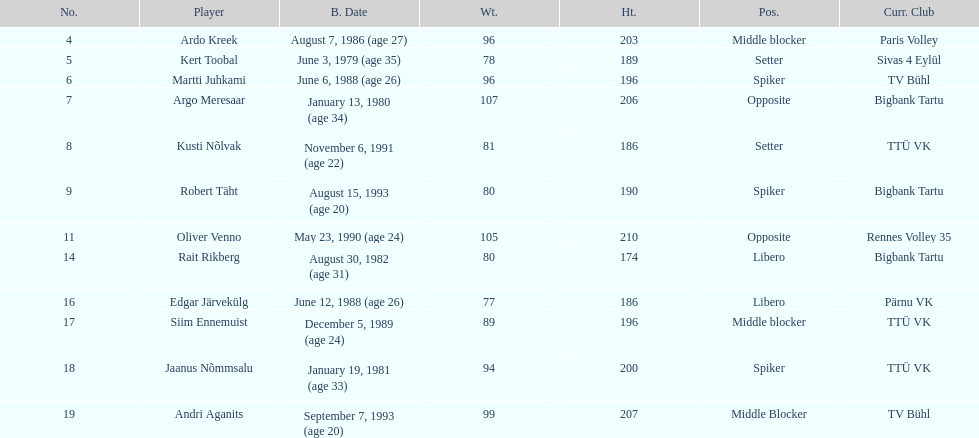How many players were born before 1988? 5. 